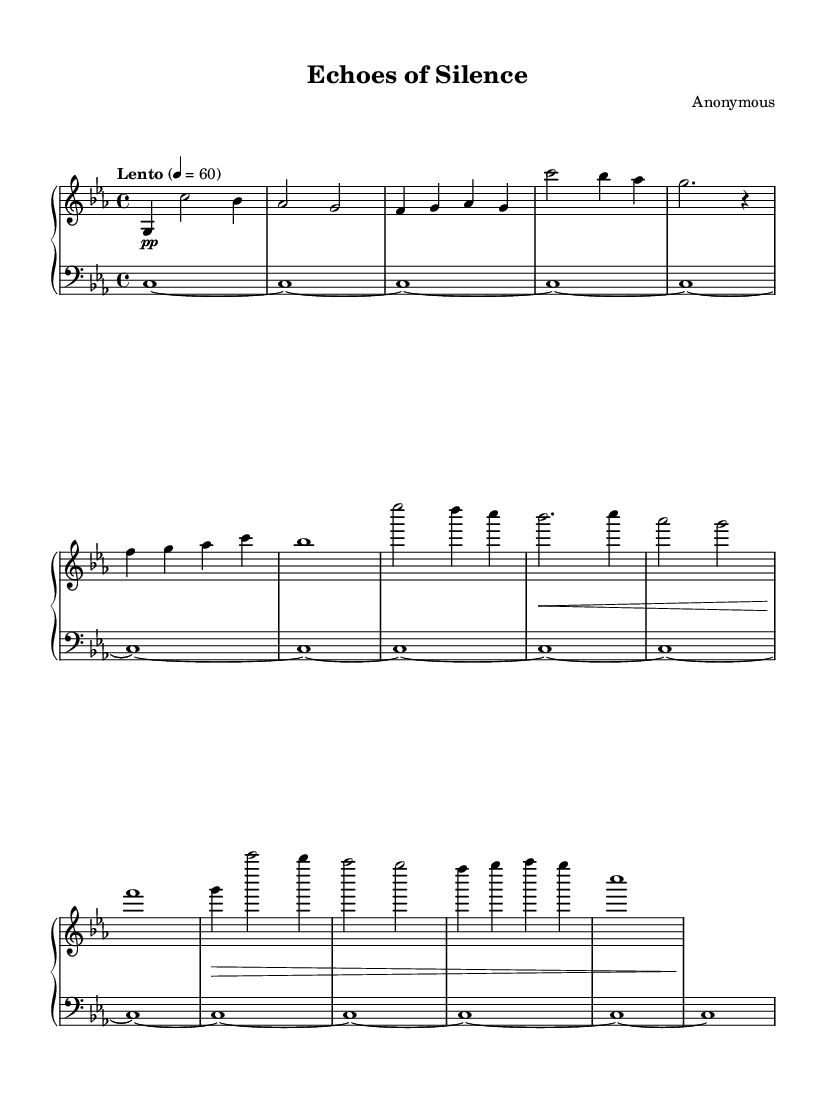What is the key signature of this music? The key signature is C minor, indicated by three flats in the key signature.
Answer: C minor What is the time signature of this piece? The time signature is 4/4, shown at the beginning of the score with a "4" above and below the staff, indicating four beats in each measure.
Answer: 4/4 What is the tempo marking for this composition? The tempo marking is "Lento," indicating a slow speed, with a metronome marking of 60 beats per minute shown in Italian notation at the beginning of the score.
Answer: Lento How many distinct themes are presented in this piece? There are two distinct themes identified as Theme A and Theme B, reflected in the structured layout of the sheet music with labels for each part.
Answer: 2 What dynamics are indicated in the piano part? The dynamics are primarily marked as piano (pp) and include crescendos and decrescendos denoting the subtleties of the performance. This is noted in the dynamics section of the score.
Answer: Piano What type of instrument is indicated for the upper staff? The upper staff is designated for an "acoustic grand," indicating that a grand piano should be used for this part of the music as per the instrument marking.
Answer: Acoustic grand What is the function of the ambient pad in this piece? The ambient pad provides a continuous harmonic backdrop, with long, sustained notes that help create an atmospheric setting for the piano melodies to unfold over time.
Answer: Atmosphere 